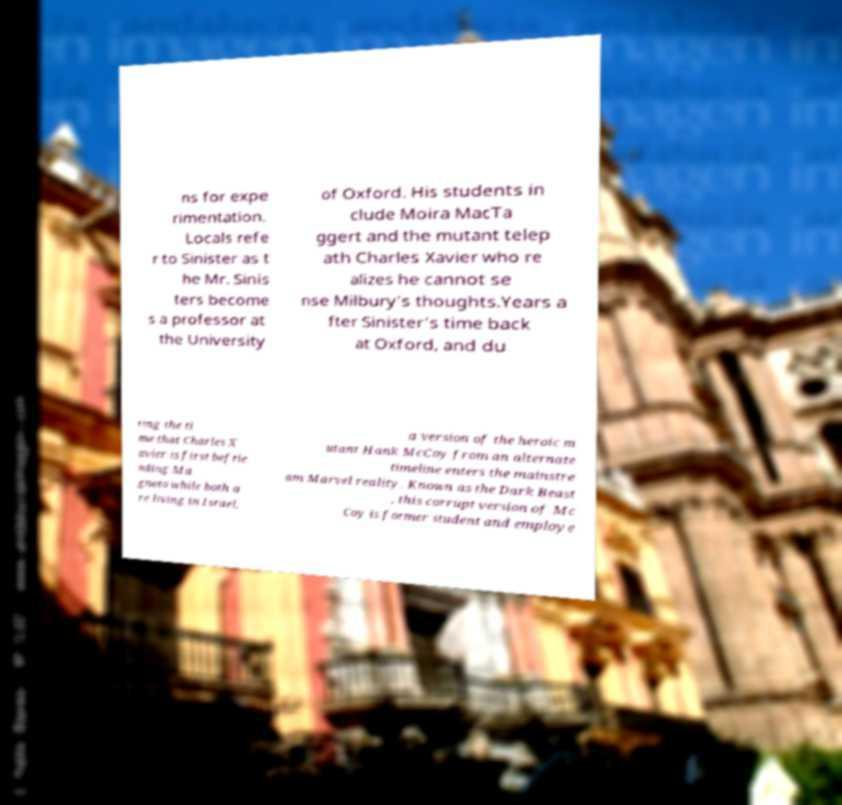Can you accurately transcribe the text from the provided image for me? ns for expe rimentation. Locals refe r to Sinister as t he Mr. Sinis ters become s a professor at the University of Oxford. His students in clude Moira MacTa ggert and the mutant telep ath Charles Xavier who re alizes he cannot se nse Milbury's thoughts.Years a fter Sinister's time back at Oxford, and du ring the ti me that Charles X avier is first befrie nding Ma gneto while both a re living in Israel, a version of the heroic m utant Hank McCoy from an alternate timeline enters the mainstre am Marvel reality. Known as the Dark Beast , this corrupt version of Mc Coy is former student and employe 